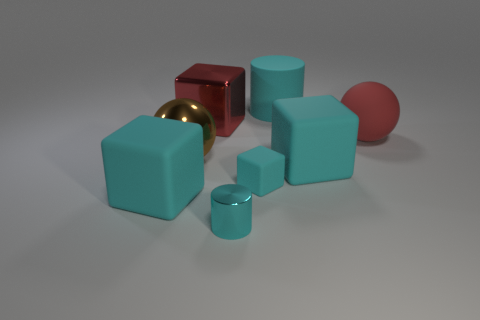Subtract all purple cylinders. How many cyan blocks are left? 3 Add 1 cyan blocks. How many objects exist? 9 Subtract 0 green blocks. How many objects are left? 8 Subtract all cyan metal objects. Subtract all big yellow rubber things. How many objects are left? 7 Add 6 large metallic balls. How many large metallic balls are left? 7 Add 5 red matte balls. How many red matte balls exist? 6 